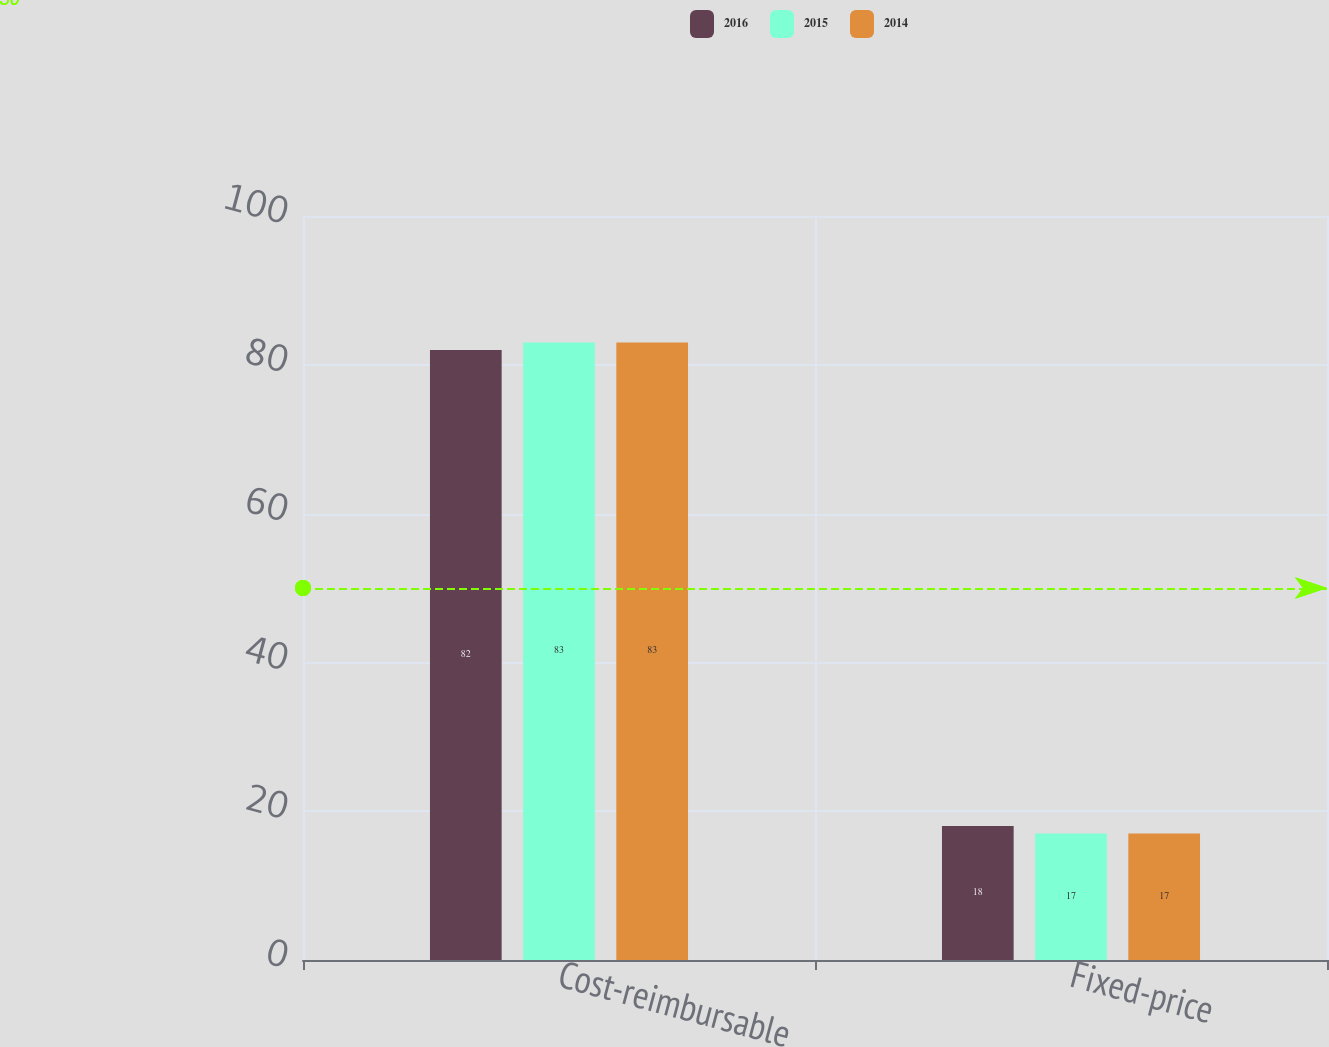Convert chart to OTSL. <chart><loc_0><loc_0><loc_500><loc_500><stacked_bar_chart><ecel><fcel>Cost-reimbursable<fcel>Fixed-price<nl><fcel>2016<fcel>82<fcel>18<nl><fcel>2015<fcel>83<fcel>17<nl><fcel>2014<fcel>83<fcel>17<nl></chart> 